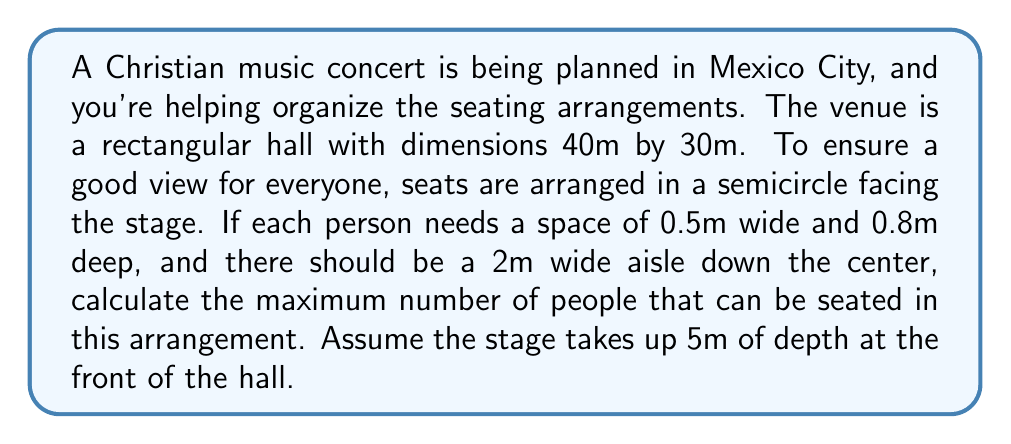Solve this math problem. Let's approach this problem step-by-step:

1) First, we need to calculate the available space for seating:
   - Length of hall: 40m
   - Depth available for seating: 40m - 5m (stage) = 35m

2) The seating area will form a semicircle. The radius of this semicircle will be the depth available:
   $r = 35m$

3) The area of a full circle would be $\pi r^2$, but we're only using half of this:
   Area of semicircle = $\frac{1}{2} \pi r^2 = \frac{1}{2} \pi (35)^2 \approx 1924.23 m^2$

4) However, we need to subtract the area of the central aisle:
   Aisle area = $2m \times 35m = 70m^2$
   Actual seating area = $1924.23m^2 - 70m^2 = 1854.23m^2$

5) Each person needs a space of:
   $0.5m \times 0.8m = 0.4m^2$

6) To find the number of people that can be seated:
   $$\text{Number of people} = \frac{\text{Actual seating area}}{\text{Area per person}} = \frac{1854.23m^2}{0.4m^2} \approx 4635.58$$

7) Since we can't have a fractional person, we round down to the nearest whole number.
Answer: The maximum number of people that can be seated is 4635. 